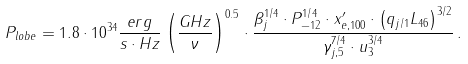Convert formula to latex. <formula><loc_0><loc_0><loc_500><loc_500>P _ { l o b e } = 1 . 8 \cdot 1 0 ^ { 3 4 } \frac { e r g } { s \cdot H z } \left ( \frac { G H z } { \nu } \right ) ^ { 0 . 5 } \cdot \frac { \beta _ { j } ^ { 1 / 4 } \cdot P _ { - 1 2 } ^ { 1 / 4 } \cdot x ^ { \prime } _ { e , 1 0 0 } \cdot \left ( q _ { j / 1 } L _ { 4 6 } \right ) ^ { 3 / 2 } } { \gamma _ { j , 5 } ^ { 7 / 4 } \cdot u _ { 3 } ^ { 3 / 4 } } \, .</formula> 